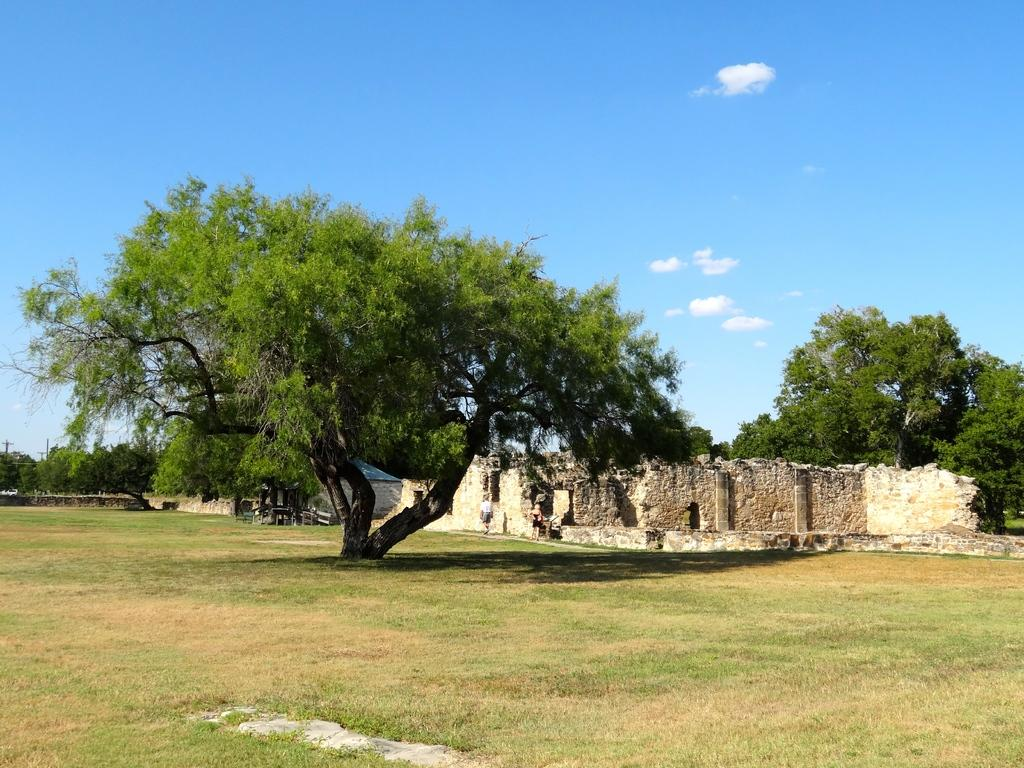How many people are present in the image? There are persons in the image, but the exact number cannot be determined from the provided facts. What structures can be seen in the image? There are buildings in the image. What type of vegetation is present in the image? There are trees in the image. What is visible in the background of the image? The sky is visible in the background of the image. Can you tell me what type of insect is crawling on the camera in the image? There is no camera or insect present in the image. 